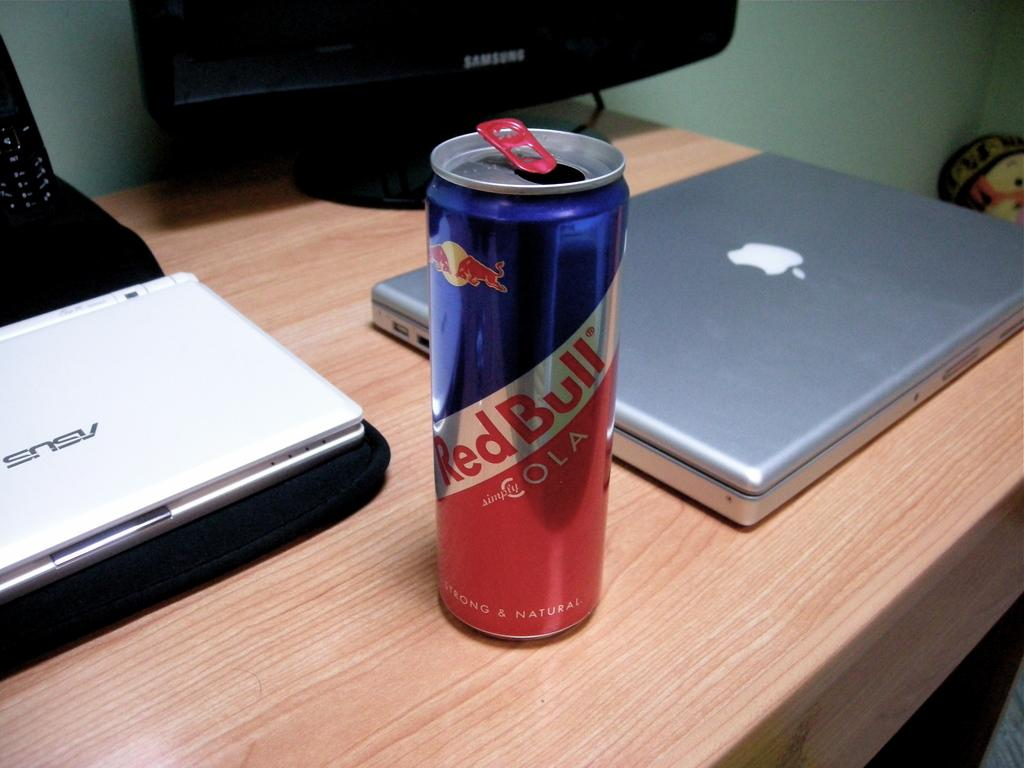<image>
Write a terse but informative summary of the picture. A can of Red Bull and a laptop are on a desk. 